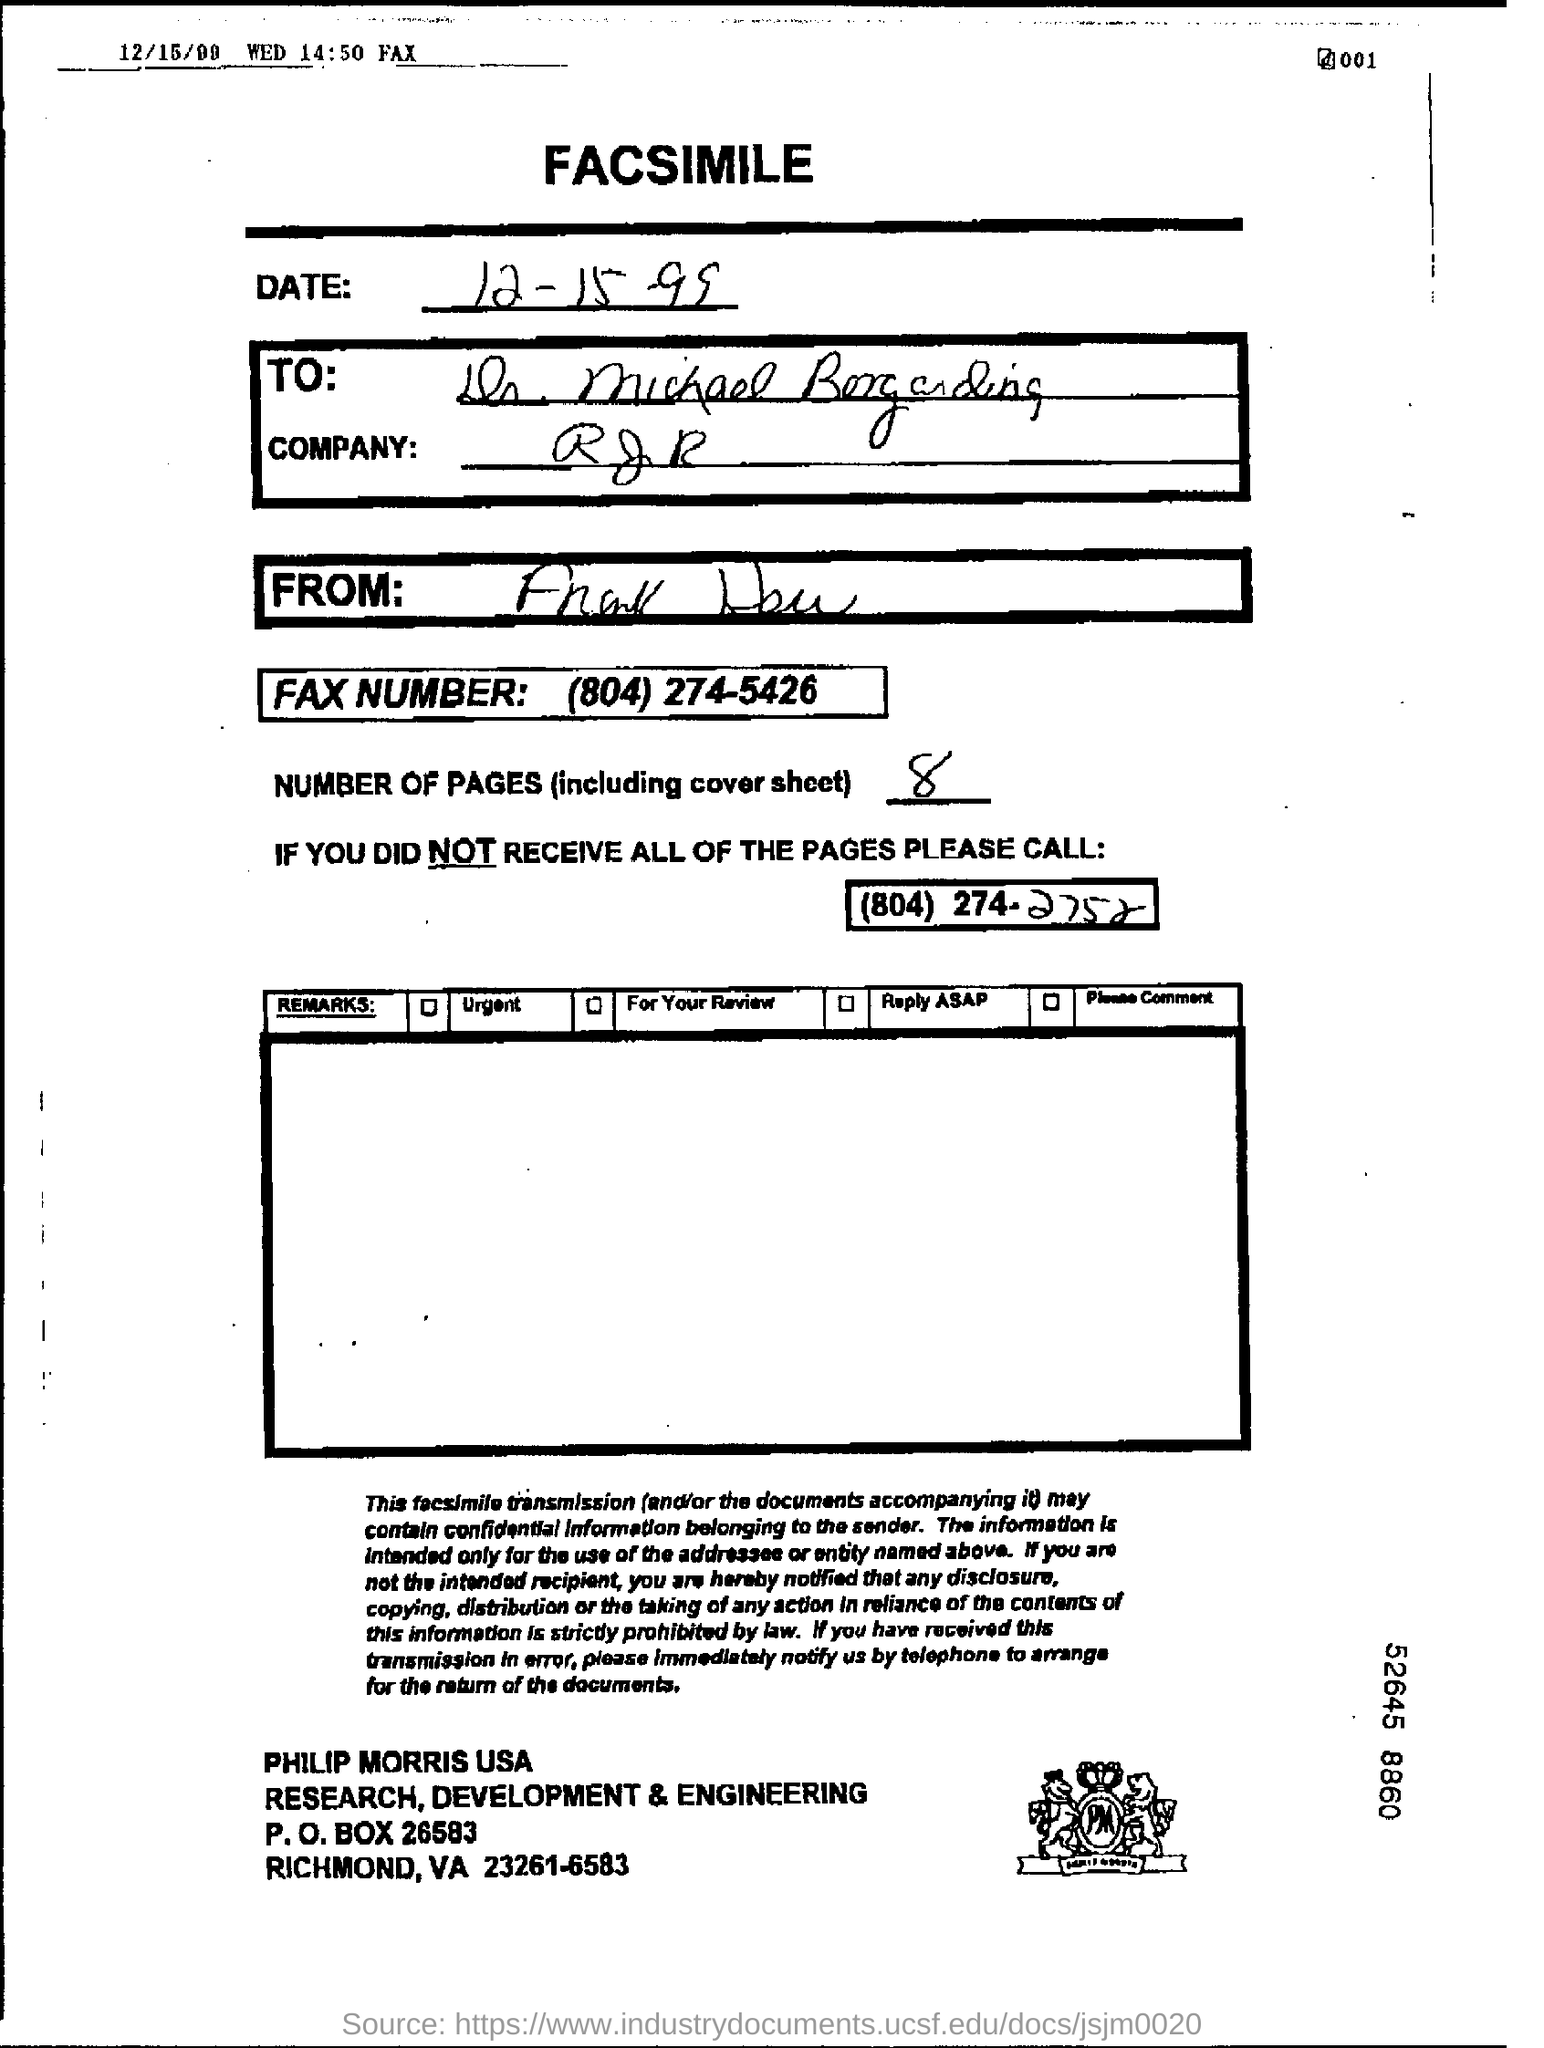Identify some key points in this picture. The facsimile message states the fax number to be 804-274-5426. The fax number is (804)274-5426. The number of pages, including the cover, is 8. The date of the document is December 15, 1999. There are 8 pages in the fax, including the cover sheet. 